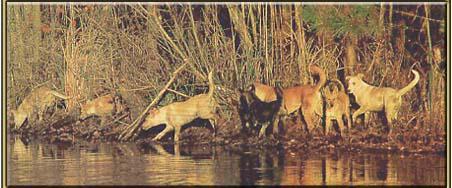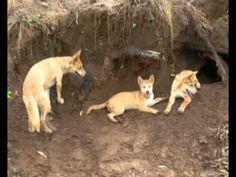The first image is the image on the left, the second image is the image on the right. Assess this claim about the two images: "Multiple dingos are at the edge of a body of water in one image.". Correct or not? Answer yes or no. Yes. The first image is the image on the left, the second image is the image on the right. For the images shown, is this caption "The dogs in one of the images are near a natural body of water." true? Answer yes or no. Yes. 